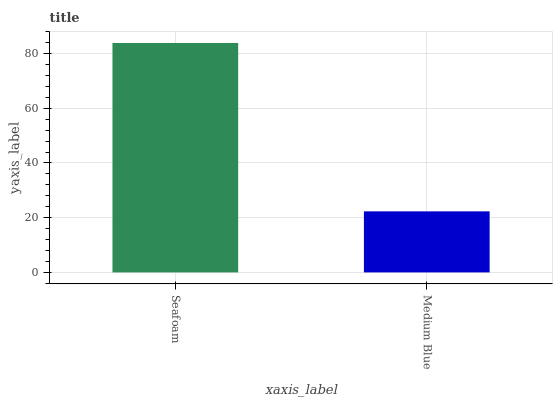Is Medium Blue the minimum?
Answer yes or no. Yes. Is Seafoam the maximum?
Answer yes or no. Yes. Is Medium Blue the maximum?
Answer yes or no. No. Is Seafoam greater than Medium Blue?
Answer yes or no. Yes. Is Medium Blue less than Seafoam?
Answer yes or no. Yes. Is Medium Blue greater than Seafoam?
Answer yes or no. No. Is Seafoam less than Medium Blue?
Answer yes or no. No. Is Seafoam the high median?
Answer yes or no. Yes. Is Medium Blue the low median?
Answer yes or no. Yes. Is Medium Blue the high median?
Answer yes or no. No. Is Seafoam the low median?
Answer yes or no. No. 